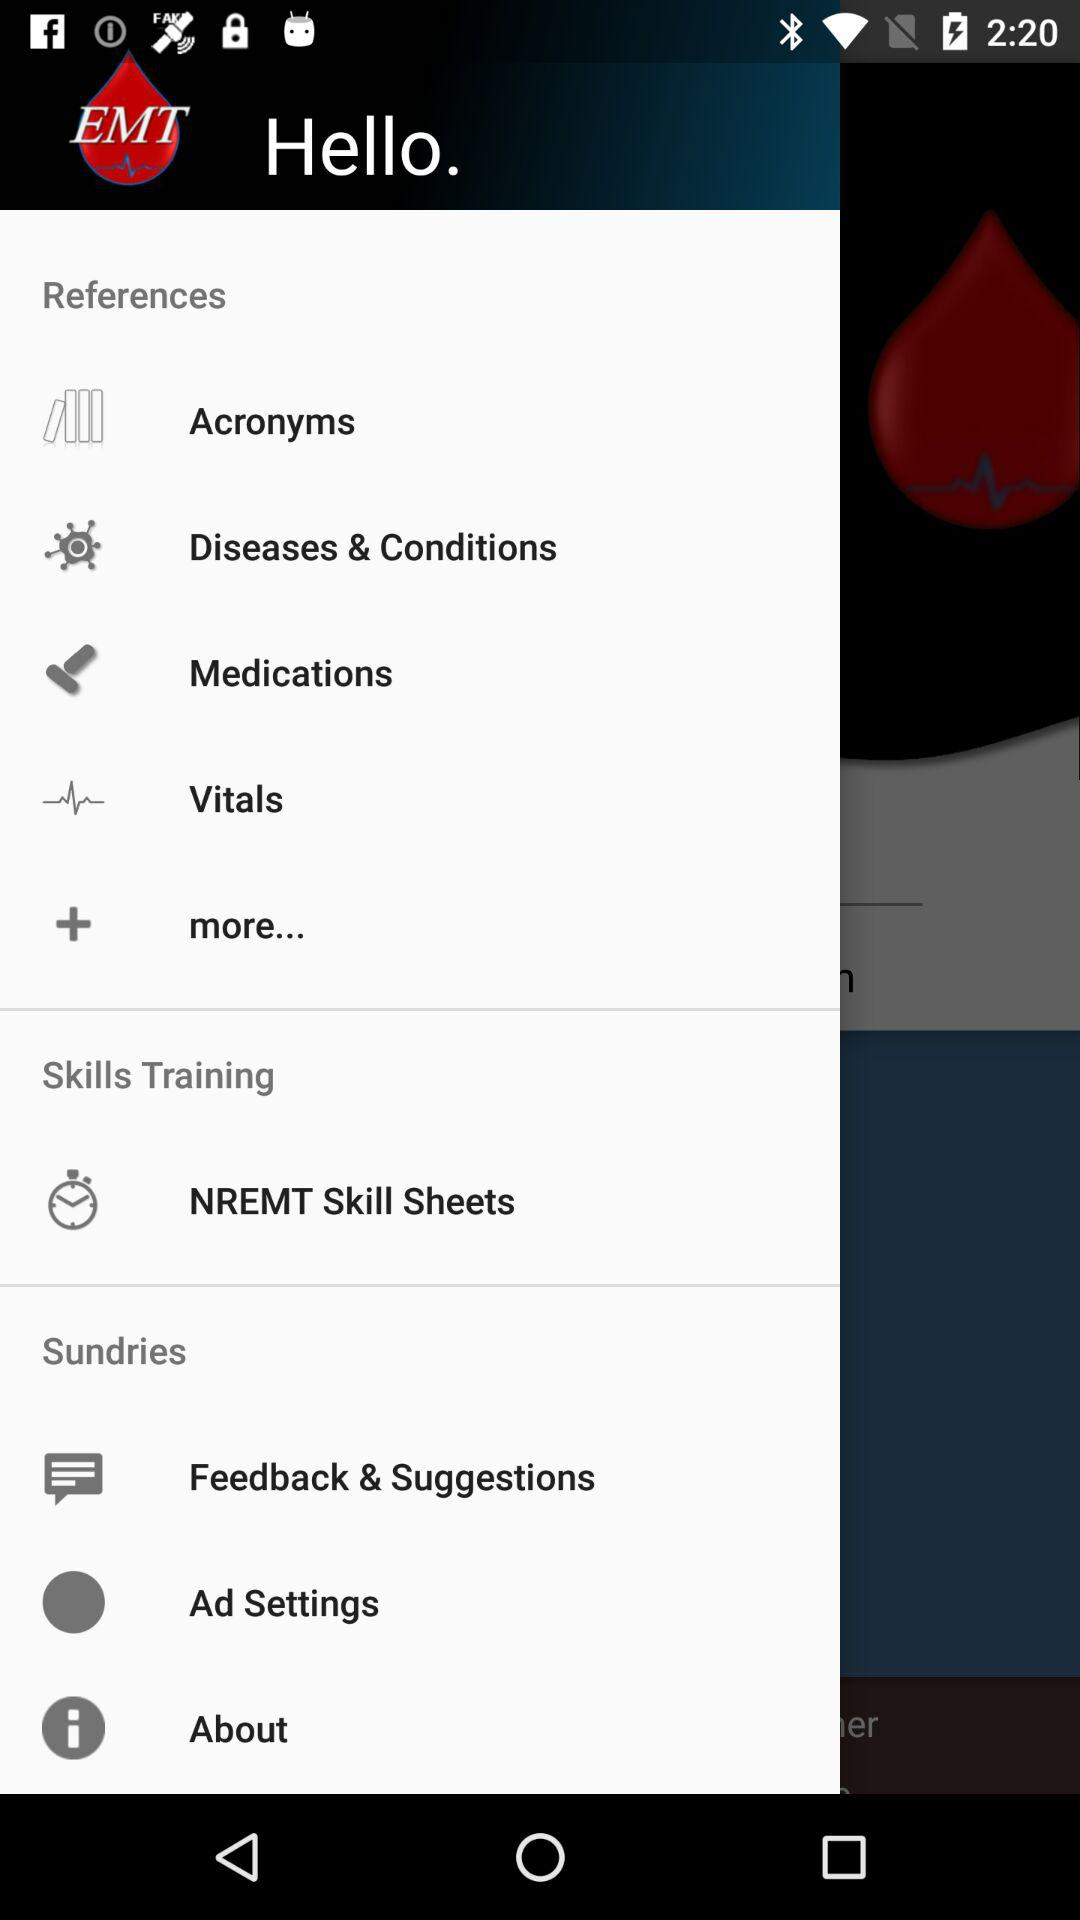What is the application name? The application name is "EMT". 